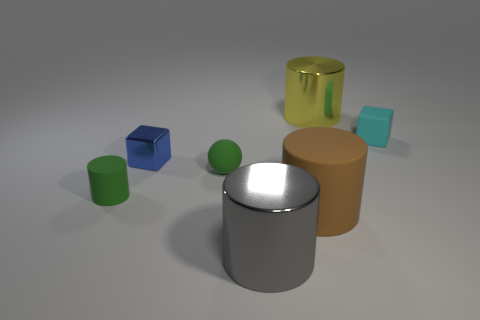Can you describe the colors and shapes of the items in the image? Certainly! The image features six items in total, with a mix of shapes and colors. Starting from the left, there's a green cylinder, a blue cube, a small green sphere, a shiny silver cylinder in the center, a large tan cylinder, and a large translucent yellow cylinder on the right. 